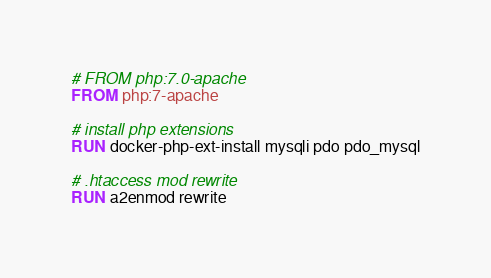Convert code to text. <code><loc_0><loc_0><loc_500><loc_500><_Dockerfile_># FROM php:7.0-apache
FROM php:7-apache

# install php extensions
RUN docker-php-ext-install mysqli pdo pdo_mysql

# .htaccess mod rewrite
RUN a2enmod rewrite
</code> 